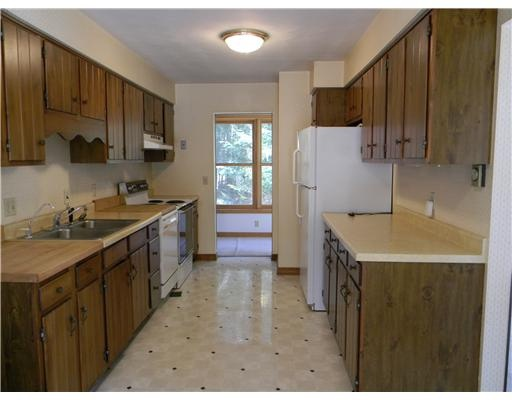Describe the objects in this image and their specific colors. I can see refrigerator in white, darkgray, and gray tones, oven in white, gray, and black tones, and sink in white, black, and gray tones in this image. 